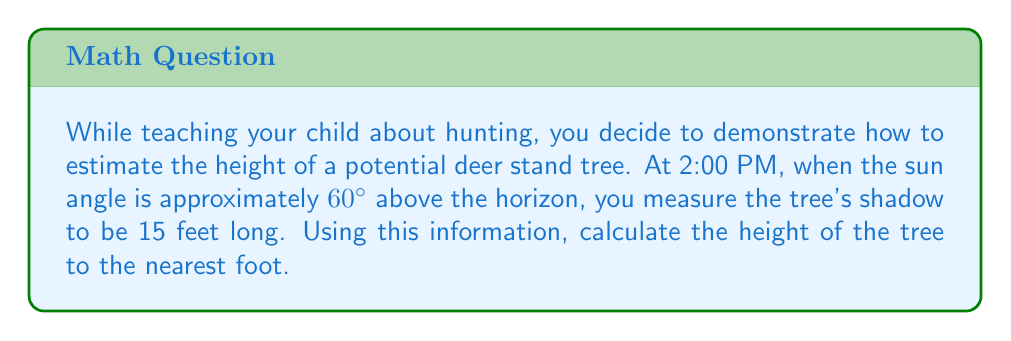Show me your answer to this math problem. Let's approach this step-by-step:

1) First, we need to identify the trigonometric ratio that relates the tree's height to its shadow length. In this case, we'll use the tangent ratio.

2) Let's draw a diagram to visualize the problem:

[asy]
unitsize(0.5cm);
draw((0,0)--(15,0),Arrow);
draw((0,0)--(0,26),Arrow);
draw((15,0)--(0,26));
draw((0,0)--(15,26),dashed);
label("15 ft (shadow)", (7.5,-1));
label("Tree height", (-1,13), W);
label("60°", (1,1), NE);
[/asy]

3) In this right triangle:
   - The adjacent side is the shadow length (15 feet)
   - The opposite side is the tree height (what we're solving for)
   - The angle is 60° (complement of the sun's angle from the horizon)

4) The tangent ratio is:

   $$\tan \theta = \frac{\text{opposite}}{\text{adjacent}} = \frac{\text{tree height}}{\text{shadow length}}$$

5) We can write this as an equation:

   $$\tan 60° = \frac{\text{tree height}}{15}$$

6) Solving for tree height:

   $$\text{tree height} = 15 \cdot \tan 60°$$

7) Now, let's calculate:
   - $\tan 60° \approx 1.7321$
   - $15 \cdot 1.7321 \approx 25.98$ feet

8) Rounding to the nearest foot gives us 26 feet.
Answer: The height of the tree is approximately 26 feet. 